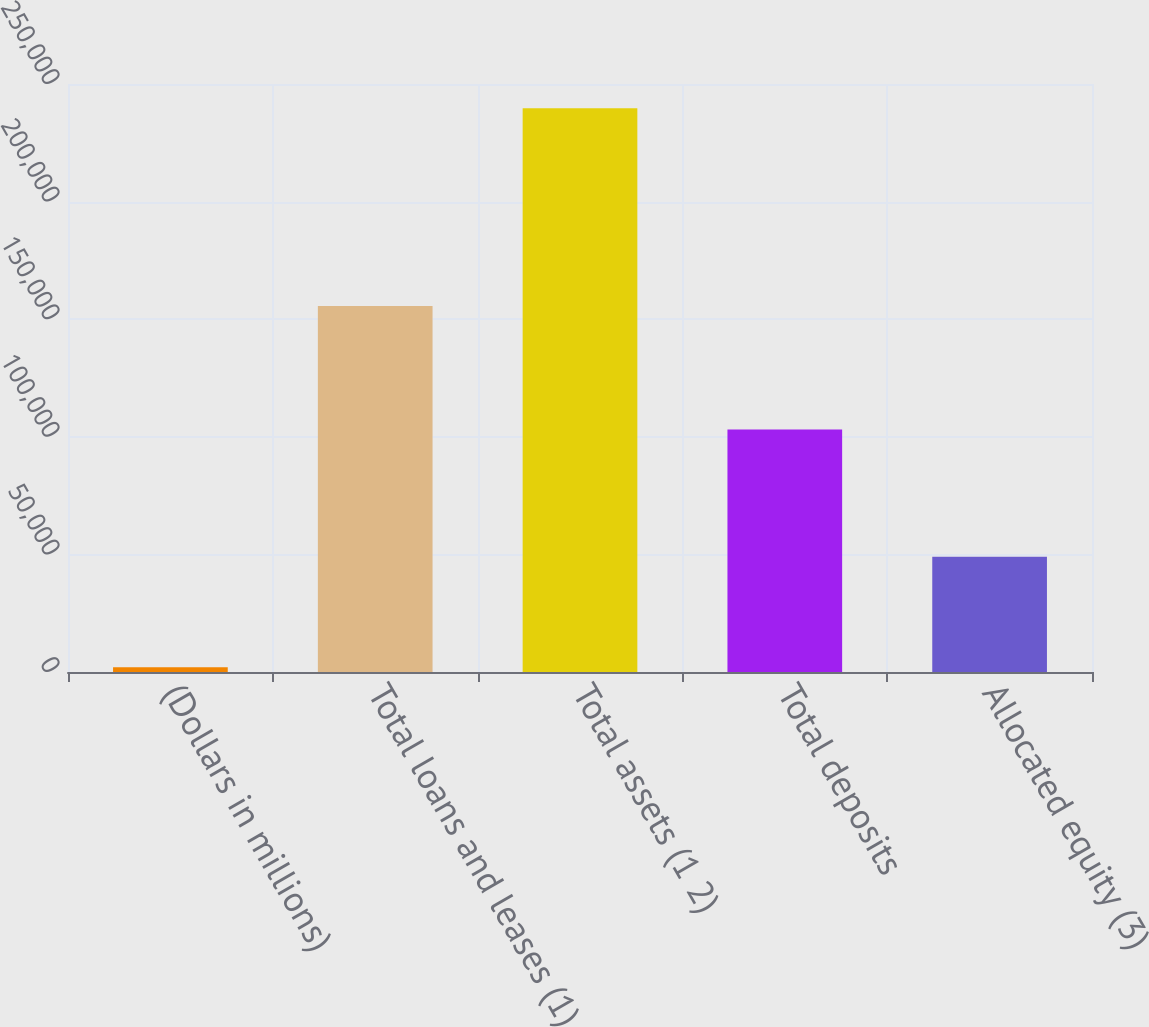Convert chart to OTSL. <chart><loc_0><loc_0><loc_500><loc_500><bar_chart><fcel>(Dollars in millions)<fcel>Total loans and leases (1)<fcel>Total assets (1 2)<fcel>Total deposits<fcel>Allocated equity (3)<nl><fcel>2009<fcel>155561<fcel>239642<fcel>103122<fcel>49015<nl></chart> 